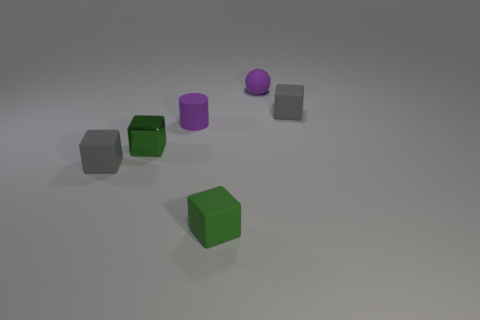Are there any blue rubber blocks?
Make the answer very short. No. Does the tiny gray object left of the purple sphere have the same material as the purple cylinder?
Make the answer very short. Yes. Are there any other green metal things that have the same shape as the green metal thing?
Offer a very short reply. No. Are there an equal number of tiny objects that are on the right side of the tiny purple rubber sphere and small metallic cylinders?
Provide a short and direct response. No. The gray object that is behind the tiny gray rubber thing in front of the small purple rubber cylinder is made of what material?
Make the answer very short. Rubber. What shape is the metallic object?
Ensure brevity in your answer.  Cube. Are there an equal number of small gray objects that are in front of the cylinder and green metallic objects to the right of the small green matte object?
Offer a very short reply. No. There is a tiny cube that is right of the green matte cube; is it the same color as the tiny rubber thing to the left of the matte cylinder?
Offer a terse response. Yes. Is the number of green cubes left of the tiny ball greater than the number of small green metal objects?
Ensure brevity in your answer.  Yes. What shape is the tiny green object that is made of the same material as the small purple cylinder?
Your answer should be compact. Cube. 